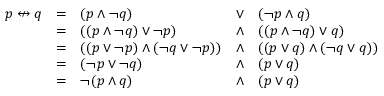Convert formula to latex. <formula><loc_0><loc_0><loc_500><loc_500>{ \begin{array} { l l l l l } { p \ n l e f t r i g h t a r r o w q } & { = } & { ( p \land \ln o t q ) } & { \lor } & { ( \ln o t p \land q ) } \\ & { = } & { ( ( p \land \ln o t q ) \lor \ln o t p ) } & { \land } & { ( ( p \land \ln o t q ) \lor q ) } \\ & { = } & { ( ( p \lor \ln o t p ) \land ( \ln o t q \lor \ln o t p ) ) } & { \land } & { ( ( p \lor q ) \land ( \ln o t q \lor q ) ) } \\ & { = } & { ( \ln o t p \lor \ln o t q ) } & { \land } & { ( p \lor q ) } \\ & { = } & { \ln o t ( p \land q ) } & { \land } & { ( p \lor q ) } \end{array} }</formula> 